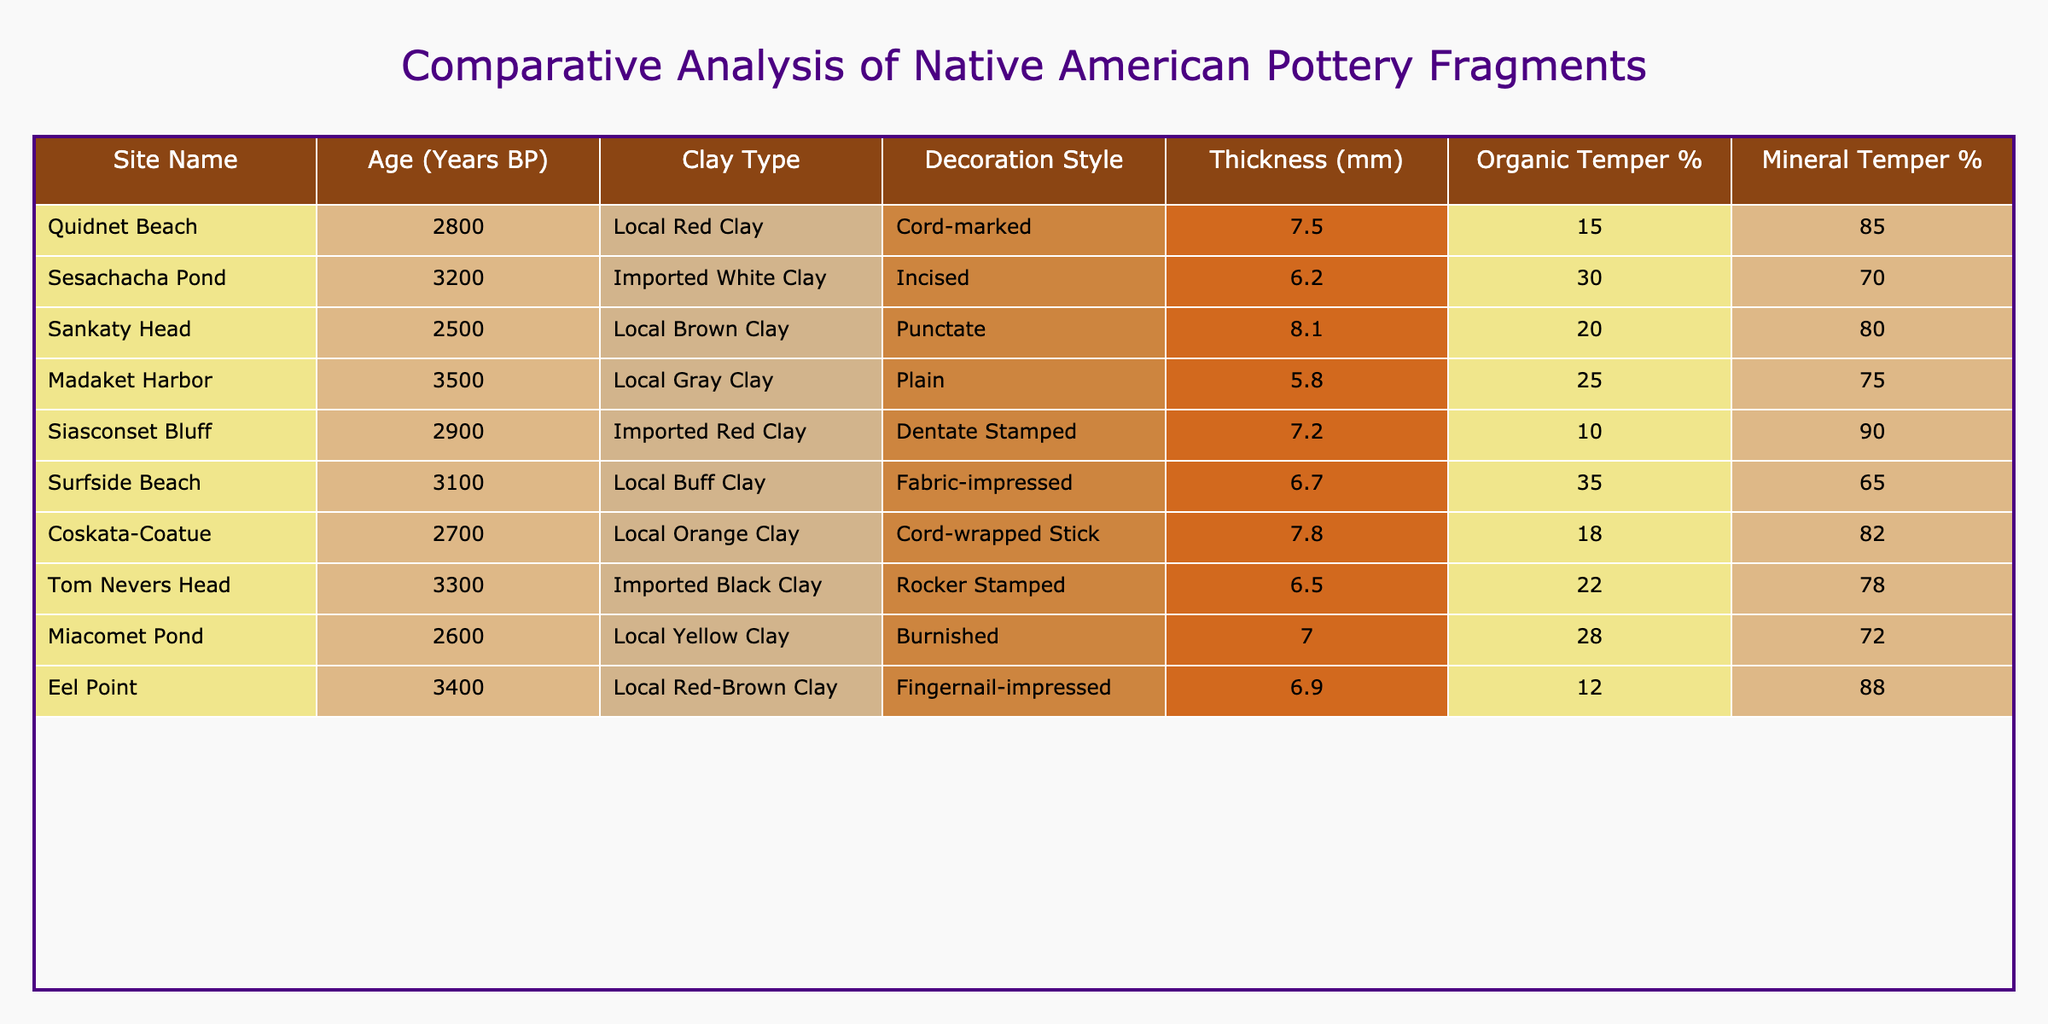What is the age of pottery fragments found at Surfside Beach? The table indicates that the age of pottery fragments at Surfside Beach is listed as 3100 years BP.
Answer: 3100 years BP Which site has the highest percentage of Organic Temper? Looking at the Organic Temper percentages in the table, Surfside Beach has the highest at 35%.
Answer: 35% What decoration style is associated with the pottery from Madaket Harbor? The table shows that the decoration style for pottery fragments found at Madaket Harbor is "Plain."
Answer: Plain What is the average thickness of pottery fragments found at Coskata-Coatue and Eel Point? The thicknesses for Coskata-Coatue and Eel Point are 7.8 mm and 6.9 mm, respectively. The average is (7.8 + 6.9) / 2 = 7.35 mm.
Answer: 7.35 mm Is there any pottery fragment found at Sankaty Head that uses Imported Clay? According to the table, Sankaty Head uses Local Brown Clay. Therefore, it does not have pottery made of Imported Clay.
Answer: No Which site has the lowest Mineral Temper percentage? By reviewing the Mineral Temper percentages, Siasconset Bluff has the lowest percentage at 10%.
Answer: 10% If we compare the ages, which site has pottery fragments dating closest to 3000 years BP? The ages closest to 3000 years BP are from Surfside Beach (3100 years BP) and Coskata-Coatue (2700 years BP). Surfside Beach is the closest at 3100 years BP.
Answer: Surfside Beach What is the total thickness of pottery fragments from Tom Nevers Head and Siasconset Bluff combined? The thickness for Tom Nevers Head is 6.5 mm and for Siasconset Bluff is 7.2 mm. Adding these gives a total thickness of 6.5 + 7.2 = 13.7 mm.
Answer: 13.7 mm How many sites have pottery fragments made from Local Clay? From the table, we can identify sites with Local Clay: Quidnet Beach, Sankaty Head, Madaket Harbor, Surfside Beach, Coskata-Coatue, Eel Point, and Miacomet Pond. This makes a total of 7 sites.
Answer: 7 sites Which decoration style is most prevalent among the sites listed? The decoration styles found in the table are Cord-marked, Incised, Punctate, Plain, Dentate Stamped, Fabric-impressed, Cord-wrapped Stick, Rocker Stamped, and Burnished. Since there is no reiteration of any styles across the sites, there is no prevalent style.
Answer: None What percentage of pottery fragments from Siasconset Bluff is based on Organic Temper? The table shows that Siasconset Bluff has 10% Organic Temper, indicating that a small portion of its composition derives from organic materials.
Answer: 10% 